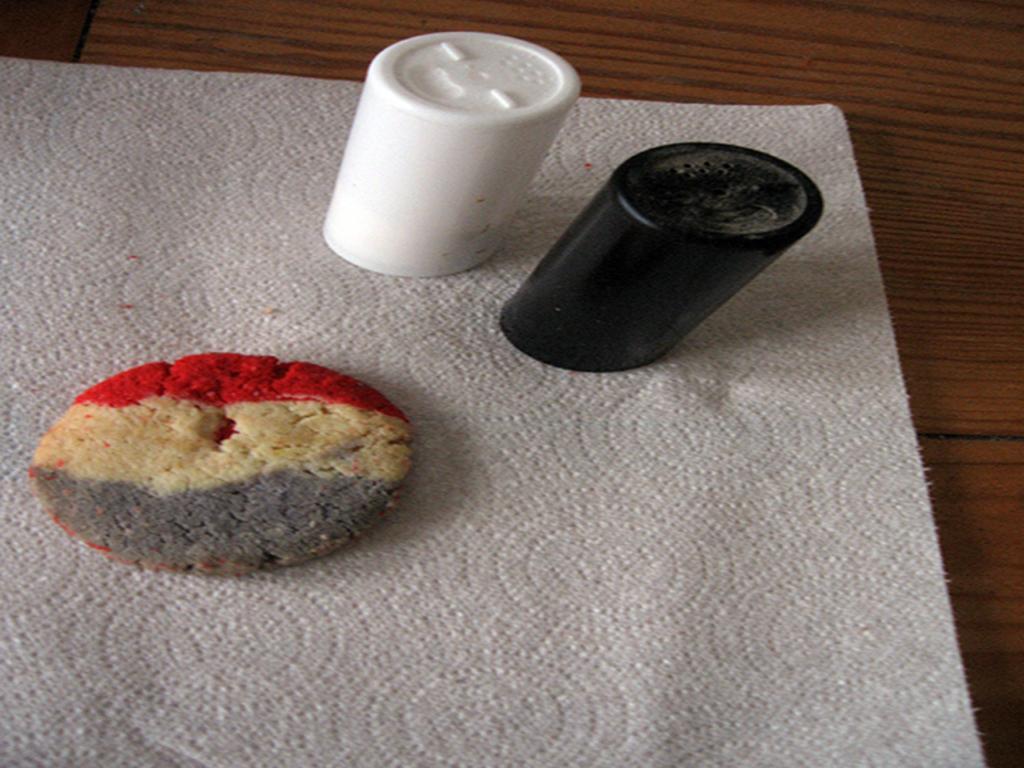Describe this image in one or two sentences. In this picture we can see a table. On the table we can see a cloth. On cloth we can see a cookie and glasses. 